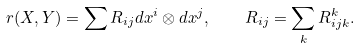<formula> <loc_0><loc_0><loc_500><loc_500>r ( X , Y ) = \sum R _ { i j } d x ^ { i } \otimes d x ^ { j } , \quad R _ { i j } = \sum _ { k } R _ { i j k } ^ { k } .</formula> 